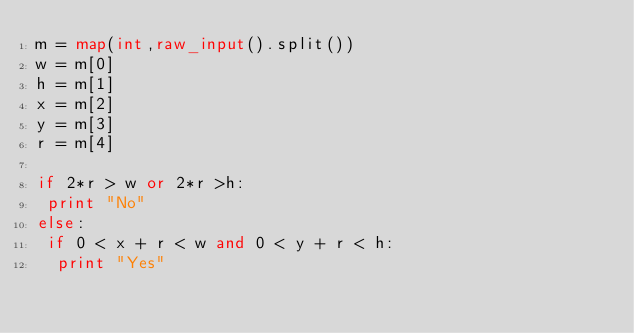<code> <loc_0><loc_0><loc_500><loc_500><_Python_>m = map(int,raw_input().split())
w = m[0]
h = m[1]
x = m[2]
y = m[3]
r = m[4]

if 2*r > w or 2*r >h:
 print "No"
else:
 if 0 < x + r < w and 0 < y + r < h:
  print "Yes"</code> 